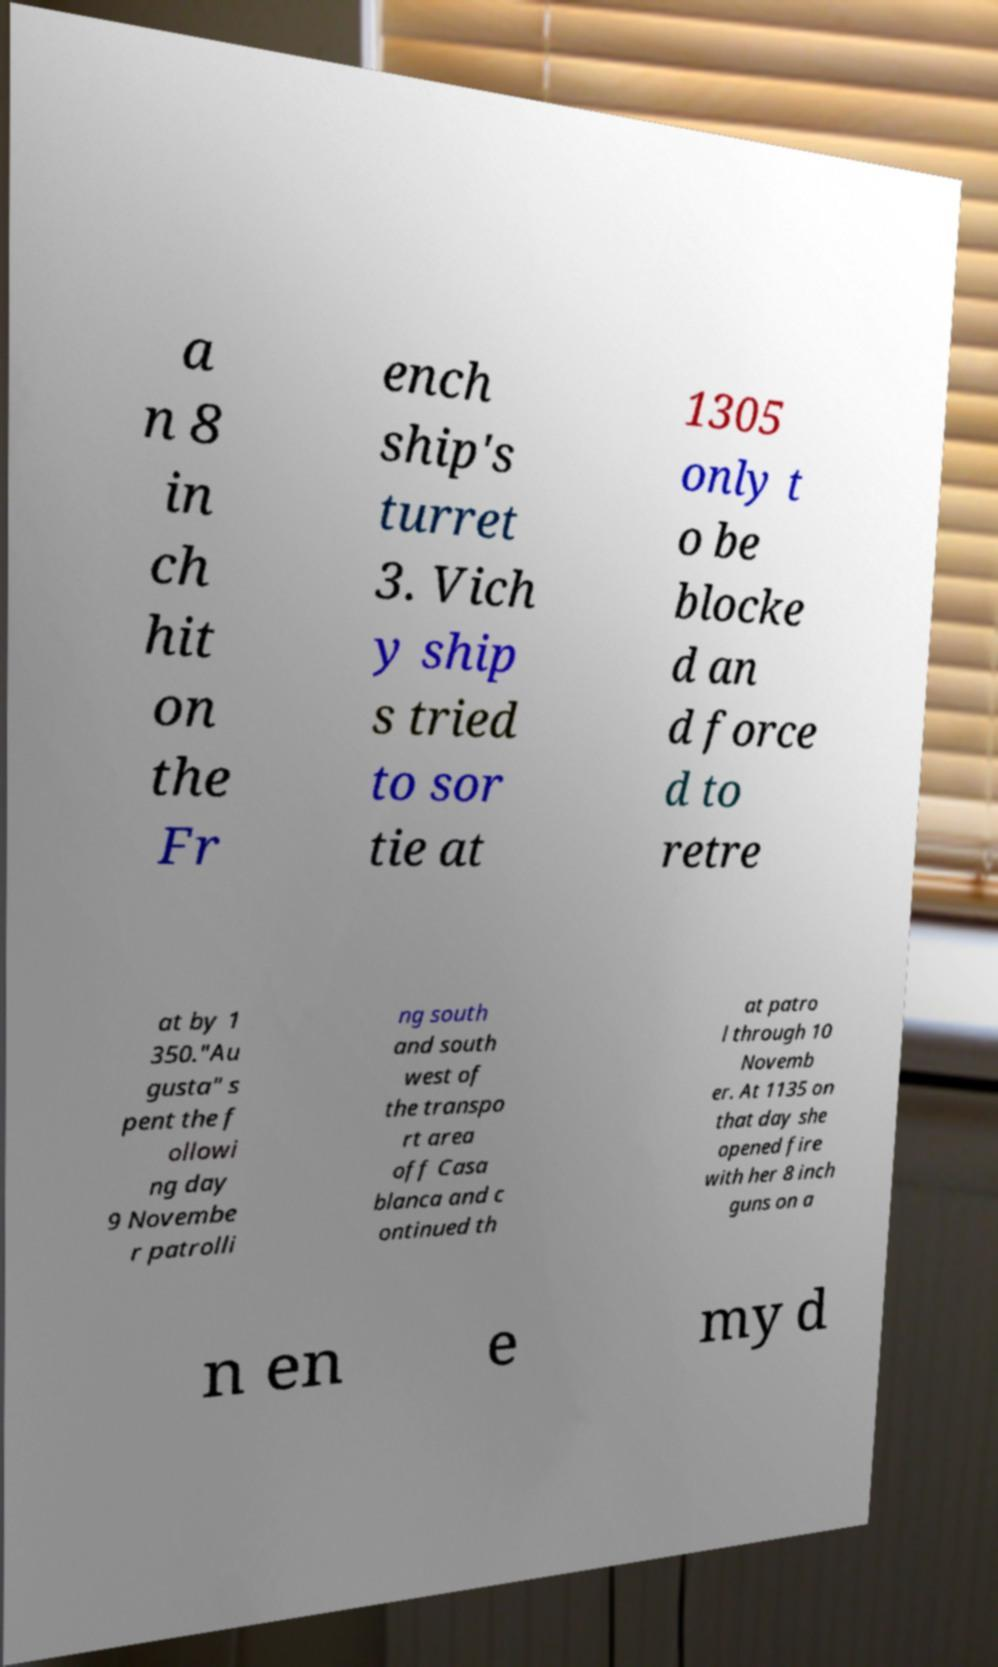Please read and relay the text visible in this image. What does it say? a n 8 in ch hit on the Fr ench ship's turret 3. Vich y ship s tried to sor tie at 1305 only t o be blocke d an d force d to retre at by 1 350."Au gusta" s pent the f ollowi ng day 9 Novembe r patrolli ng south and south west of the transpo rt area off Casa blanca and c ontinued th at patro l through 10 Novemb er. At 1135 on that day she opened fire with her 8 inch guns on a n en e my d 